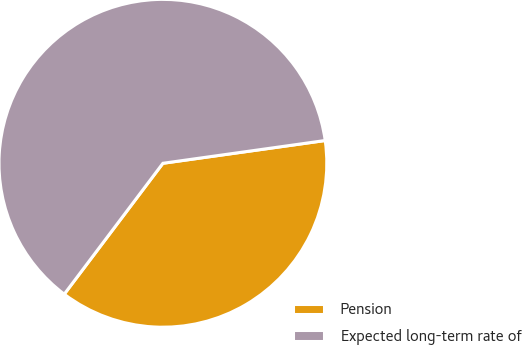<chart> <loc_0><loc_0><loc_500><loc_500><pie_chart><fcel>Pension<fcel>Expected long-term rate of<nl><fcel>37.5%<fcel>62.5%<nl></chart> 